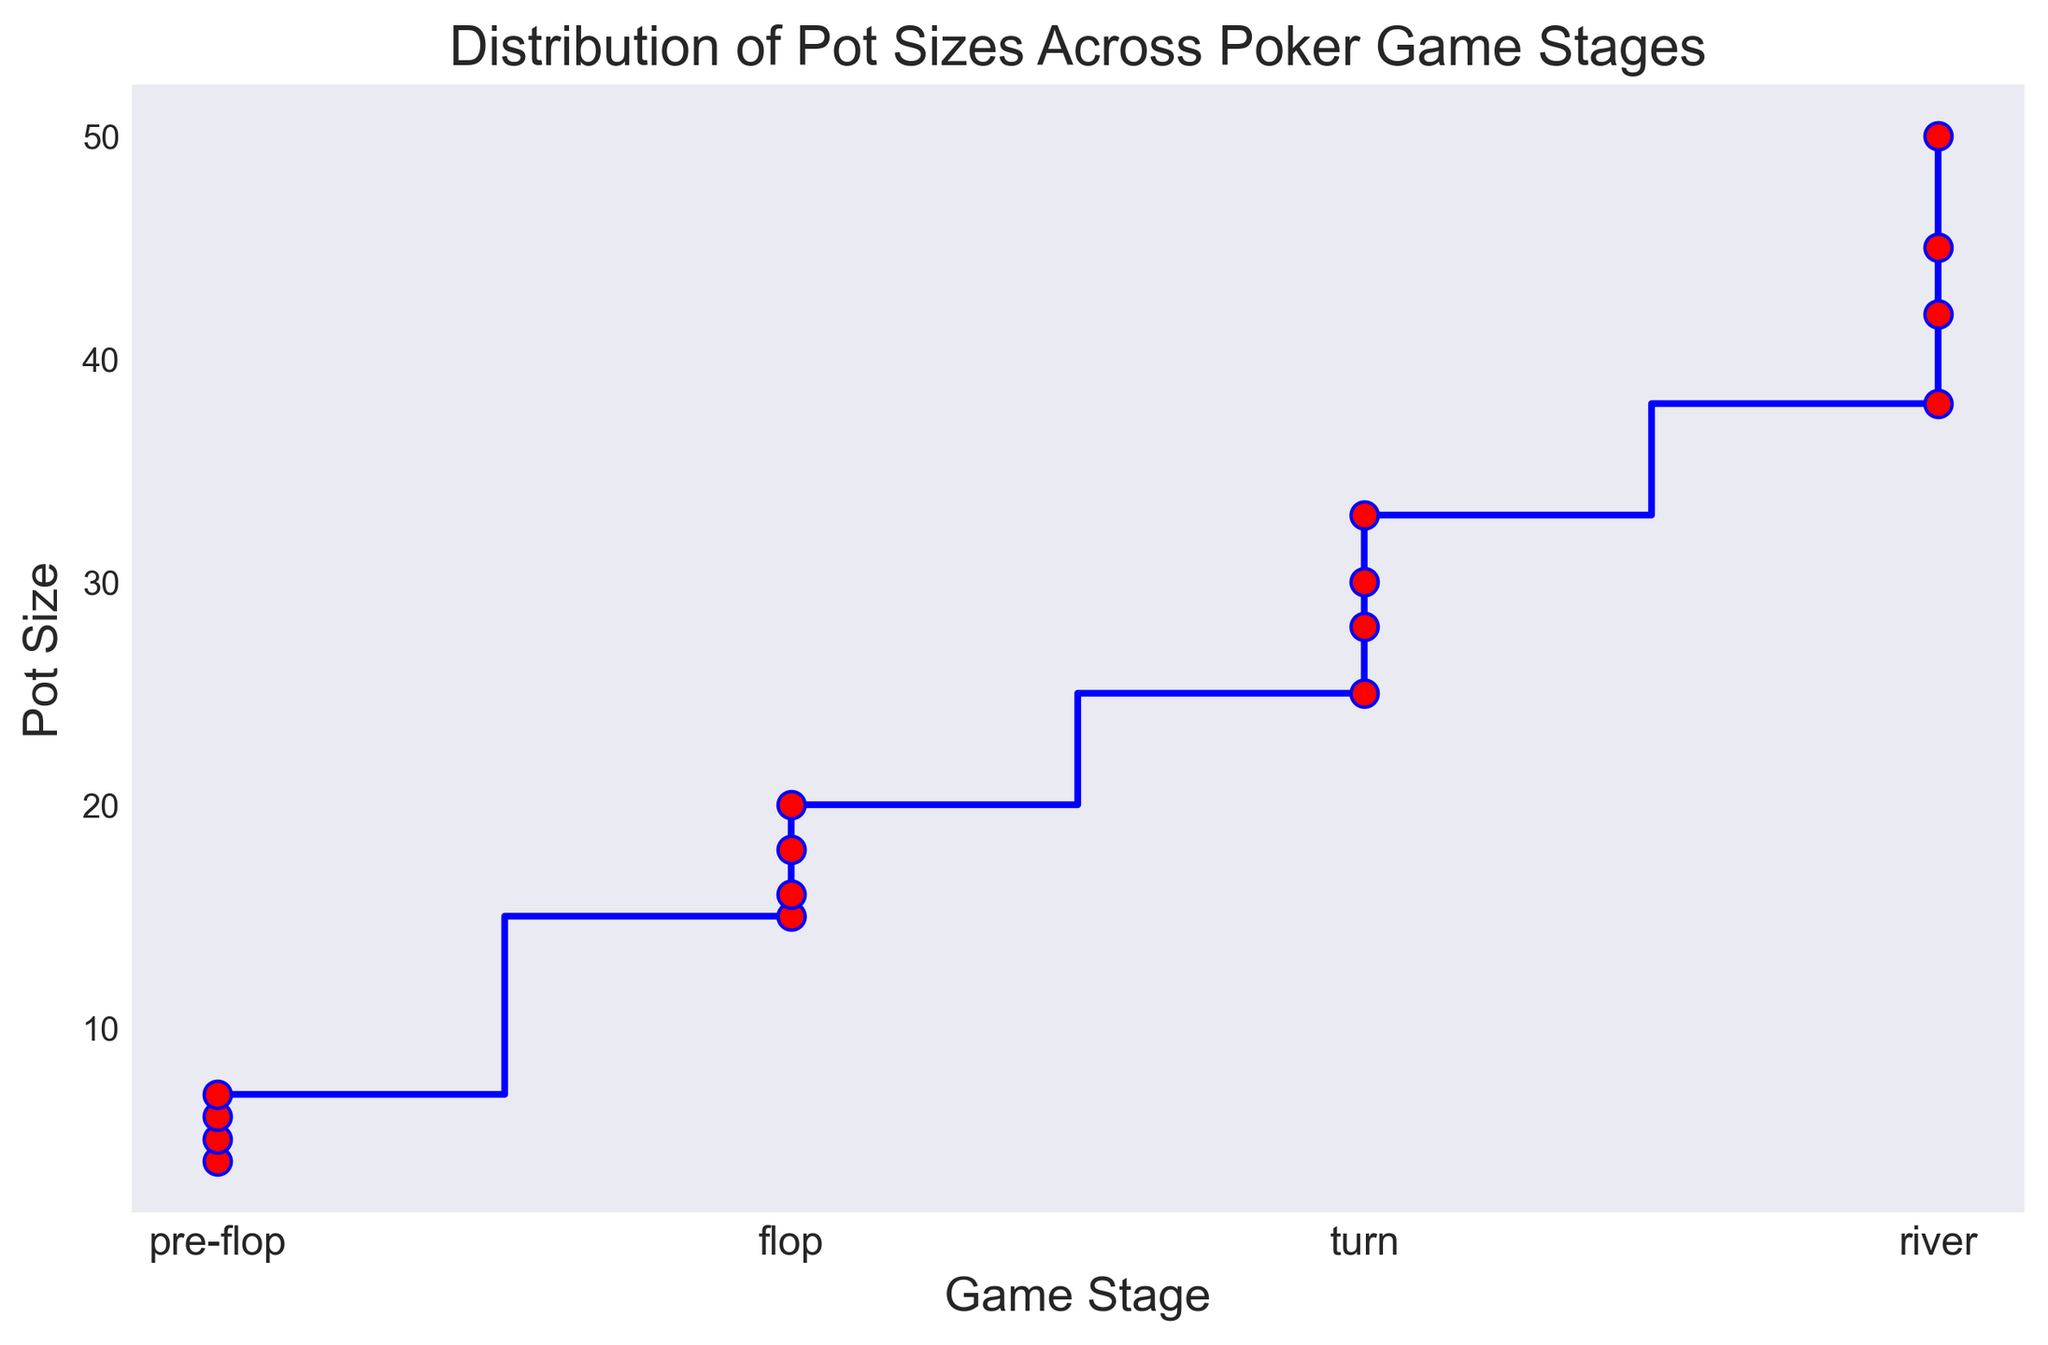What's the maximum pot size at the river stage? By looking at the section of the plot labeled "River," we identify the highest y-axis value. The highest pot size marker in this section is at 50.
Answer: 50 Is the average pot size higher at the flop stage or the turn stage? First, we need to calculate the average pot size for both stages. For the Flop stage, we add up the pot sizes (15, 18, 16, 20) and divide by the number of entries (4). For the Turn stage, we do the same for the pot sizes (25, 30, 28, 33). Calculations: 
Flop: (15 + 18 + 16 + 20) / 4 = 69 / 4 = 17.25
Turn: (25 + 30 + 28 + 33) / 4 = 116 / 4 = 29 
Therefore, the average pot size is higher at the Turn stage.
Answer: Turn stage How many stages have an average pot size above 20? Calculate the average for each stage:
Pre-flop: (5 + 7 + 6 + 4) / 4 = 22 / 4 = 5.5
Flop: (15 + 18 + 16 + 20) / 4 = 69 / 4 = 17.25
Turn: (25 + 30 + 28 + 33) / 4 = 116 / 4 = 29
River: (42 + 38 + 45 + 50) / 4 = 175 / 4 = 43.75
Only the Turn and River stages have average pot sizes above 20, which makes 2 stages.
Answer: 2 What is the difference between the maximum pot sizes at the Turn and River stages? The maximum pot size at the Turn stage is 33, and at the River stage, it's 50. The difference is calculated as 50 - 33.
Answer: 17 During which stage is there a noticeable increase in the minimum pot size compared to the previous stage? By evaluating the minimum pot sizes in each stage, we see:
Pre-flop: Minimum is 4
Flop: Minimum is 15
Turn: Minimum is 25
River: Minimum is 38
There is a noticeable increase in the minimum pot size from Flop (15) to Turn (25).
Answer: Turn stage 